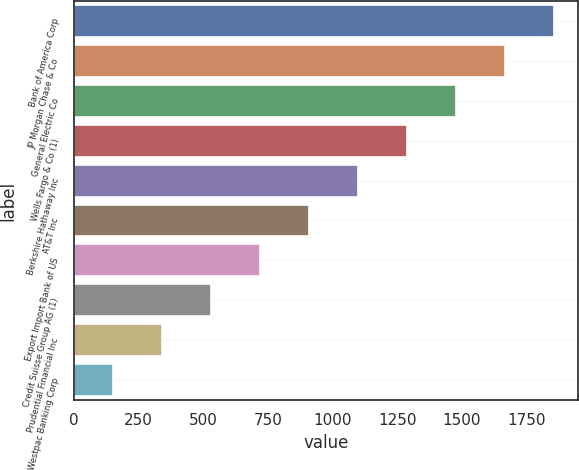Convert chart to OTSL. <chart><loc_0><loc_0><loc_500><loc_500><bar_chart><fcel>Bank of America Corp<fcel>JP Morgan Chase & Co<fcel>General Electric Co<fcel>Wells Fargo & Co (1)<fcel>Berkshire Hathaway Inc<fcel>AT&T Inc<fcel>Export Import Bank of US<fcel>Credit Suisse Group AG (1)<fcel>Prudential Financial Inc<fcel>Westpac Banking Corp<nl><fcel>1854.84<fcel>1665.38<fcel>1475.92<fcel>1286.46<fcel>1097<fcel>907.54<fcel>718.08<fcel>528.62<fcel>339.16<fcel>149.7<nl></chart> 